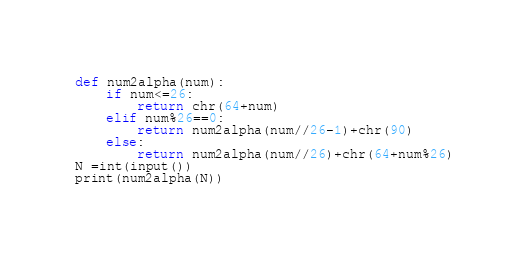Convert code to text. <code><loc_0><loc_0><loc_500><loc_500><_Python_>def num2alpha(num):
    if num<=26:
        return chr(64+num)
    elif num%26==0:
        return num2alpha(num//26-1)+chr(90)
    else:
        return num2alpha(num//26)+chr(64+num%26)
N =int(input())
print(num2alpha(N))</code> 